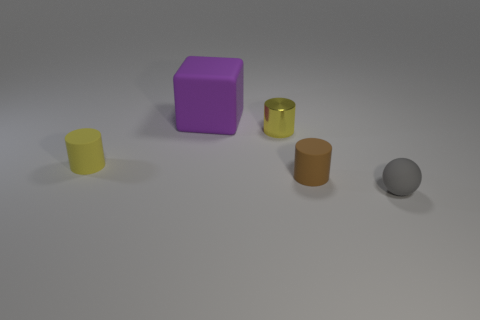Is there a cylinder of the same color as the metallic thing?
Offer a terse response. Yes. There is a matte cylinder that is the same color as the metal cylinder; what is its size?
Provide a short and direct response. Small. What shape is the other object that is the same color as the metallic object?
Make the answer very short. Cylinder. Is there anything else of the same color as the metal thing?
Provide a succinct answer. Yes. The small matte thing right of the matte cylinder on the right side of the small yellow cylinder that is left of the yellow metallic cylinder is what color?
Ensure brevity in your answer.  Gray. The rubber object behind the yellow cylinder that is to the left of the purple thing is what shape?
Ensure brevity in your answer.  Cube. Are there more small gray spheres that are behind the purple matte cube than metallic things?
Your answer should be compact. No. There is a tiny yellow object behind the tiny yellow rubber cylinder; is it the same shape as the yellow matte object?
Keep it short and to the point. Yes. Are there any other tiny rubber objects that have the same shape as the tiny brown matte thing?
Offer a very short reply. Yes. How many things are small cylinders that are behind the small brown cylinder or tiny brown cylinders?
Your answer should be compact. 3. 